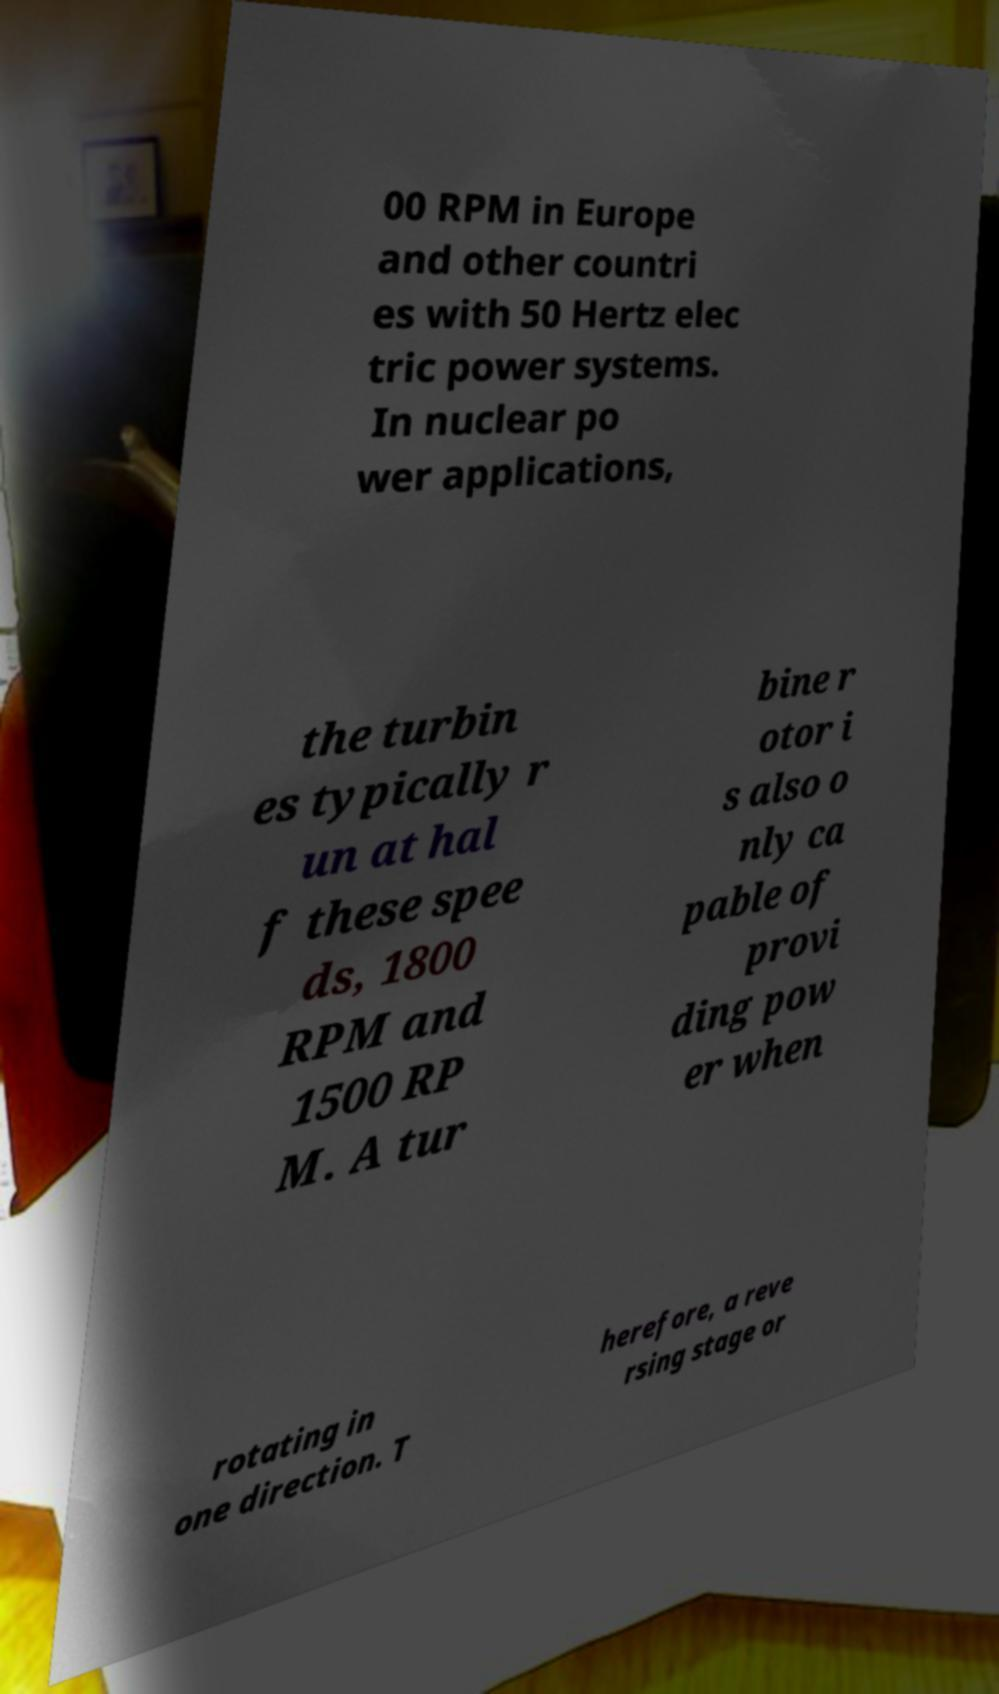For documentation purposes, I need the text within this image transcribed. Could you provide that? 00 RPM in Europe and other countri es with 50 Hertz elec tric power systems. In nuclear po wer applications, the turbin es typically r un at hal f these spee ds, 1800 RPM and 1500 RP M. A tur bine r otor i s also o nly ca pable of provi ding pow er when rotating in one direction. T herefore, a reve rsing stage or 